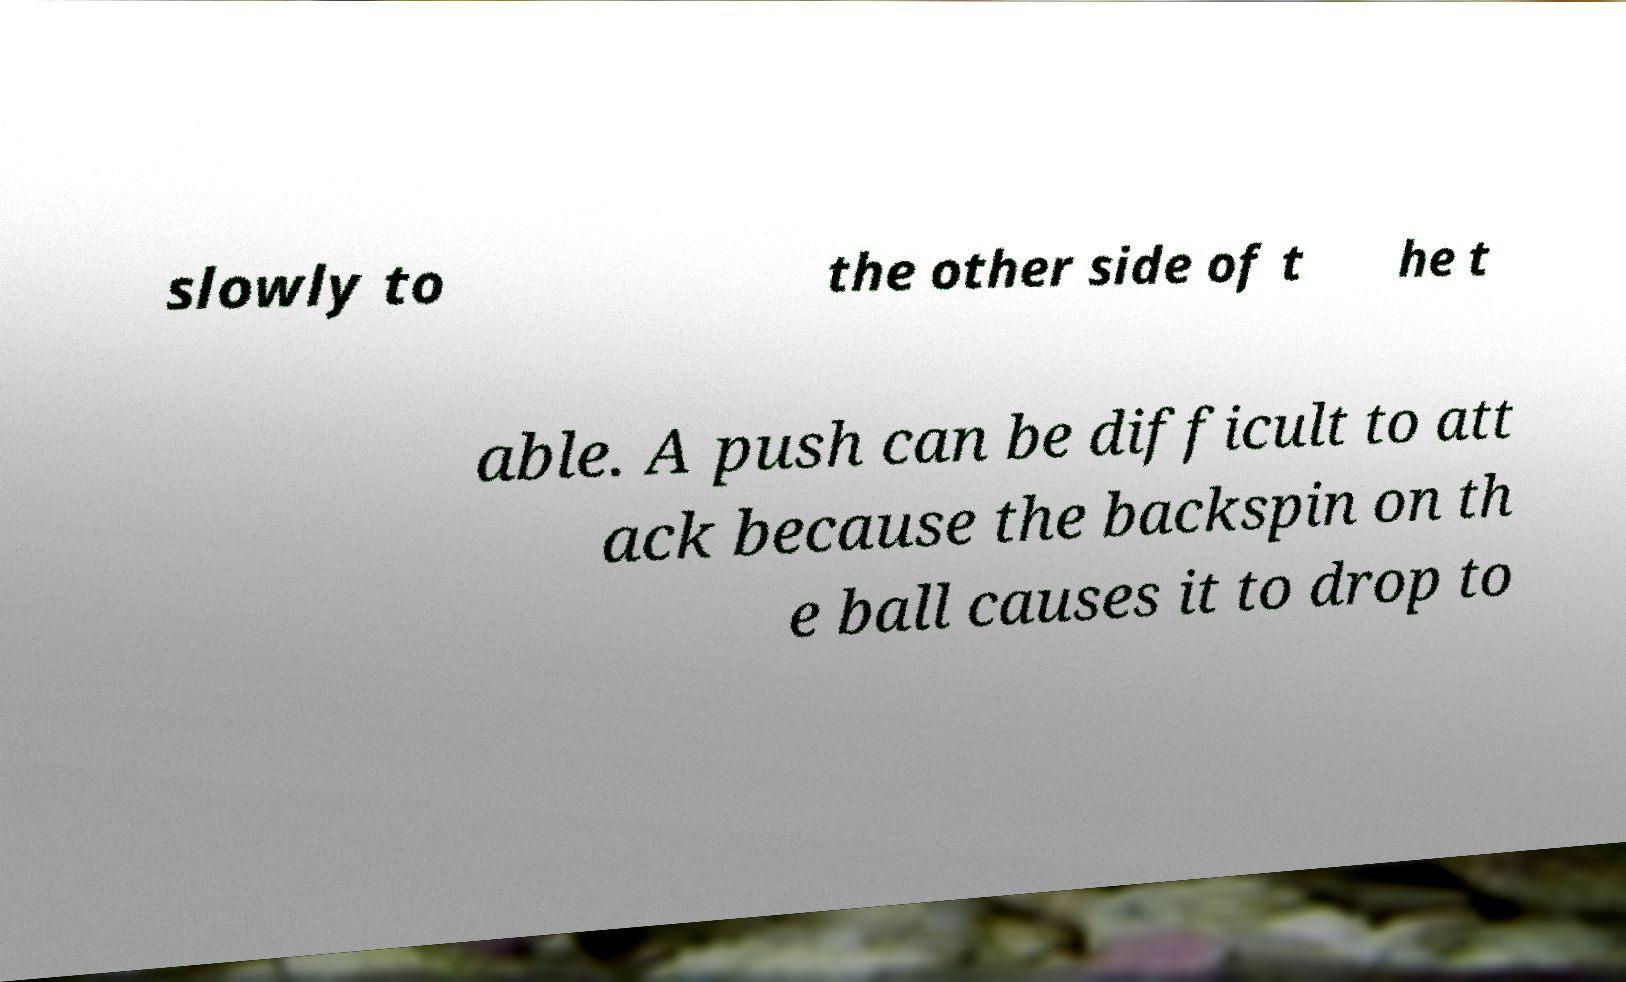Please read and relay the text visible in this image. What does it say? slowly to the other side of t he t able. A push can be difficult to att ack because the backspin on th e ball causes it to drop to 